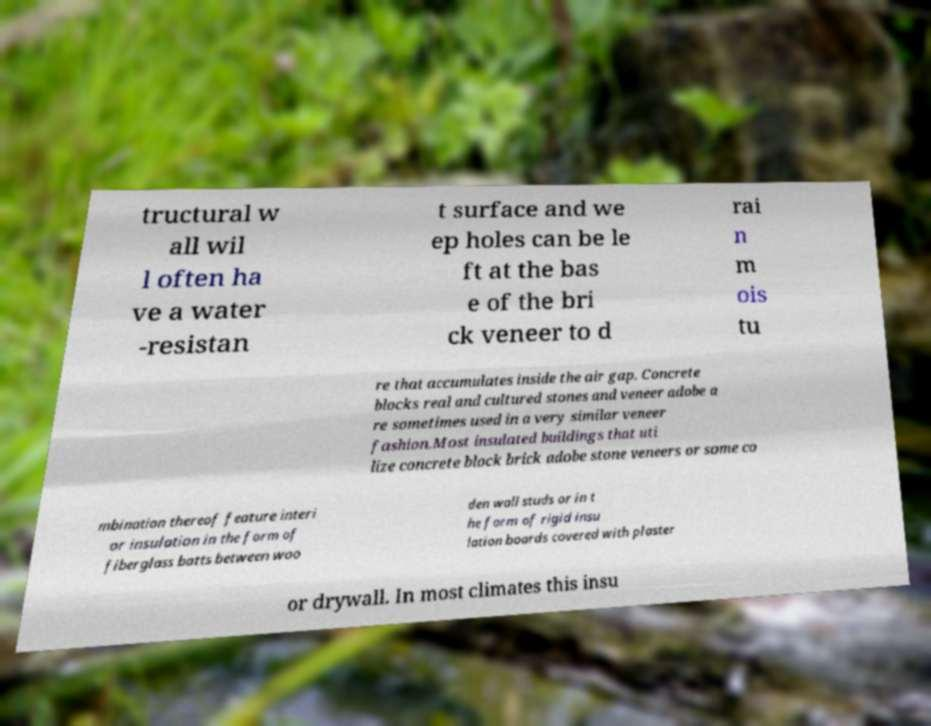I need the written content from this picture converted into text. Can you do that? tructural w all wil l often ha ve a water -resistan t surface and we ep holes can be le ft at the bas e of the bri ck veneer to d rai n m ois tu re that accumulates inside the air gap. Concrete blocks real and cultured stones and veneer adobe a re sometimes used in a very similar veneer fashion.Most insulated buildings that uti lize concrete block brick adobe stone veneers or some co mbination thereof feature interi or insulation in the form of fiberglass batts between woo den wall studs or in t he form of rigid insu lation boards covered with plaster or drywall. In most climates this insu 